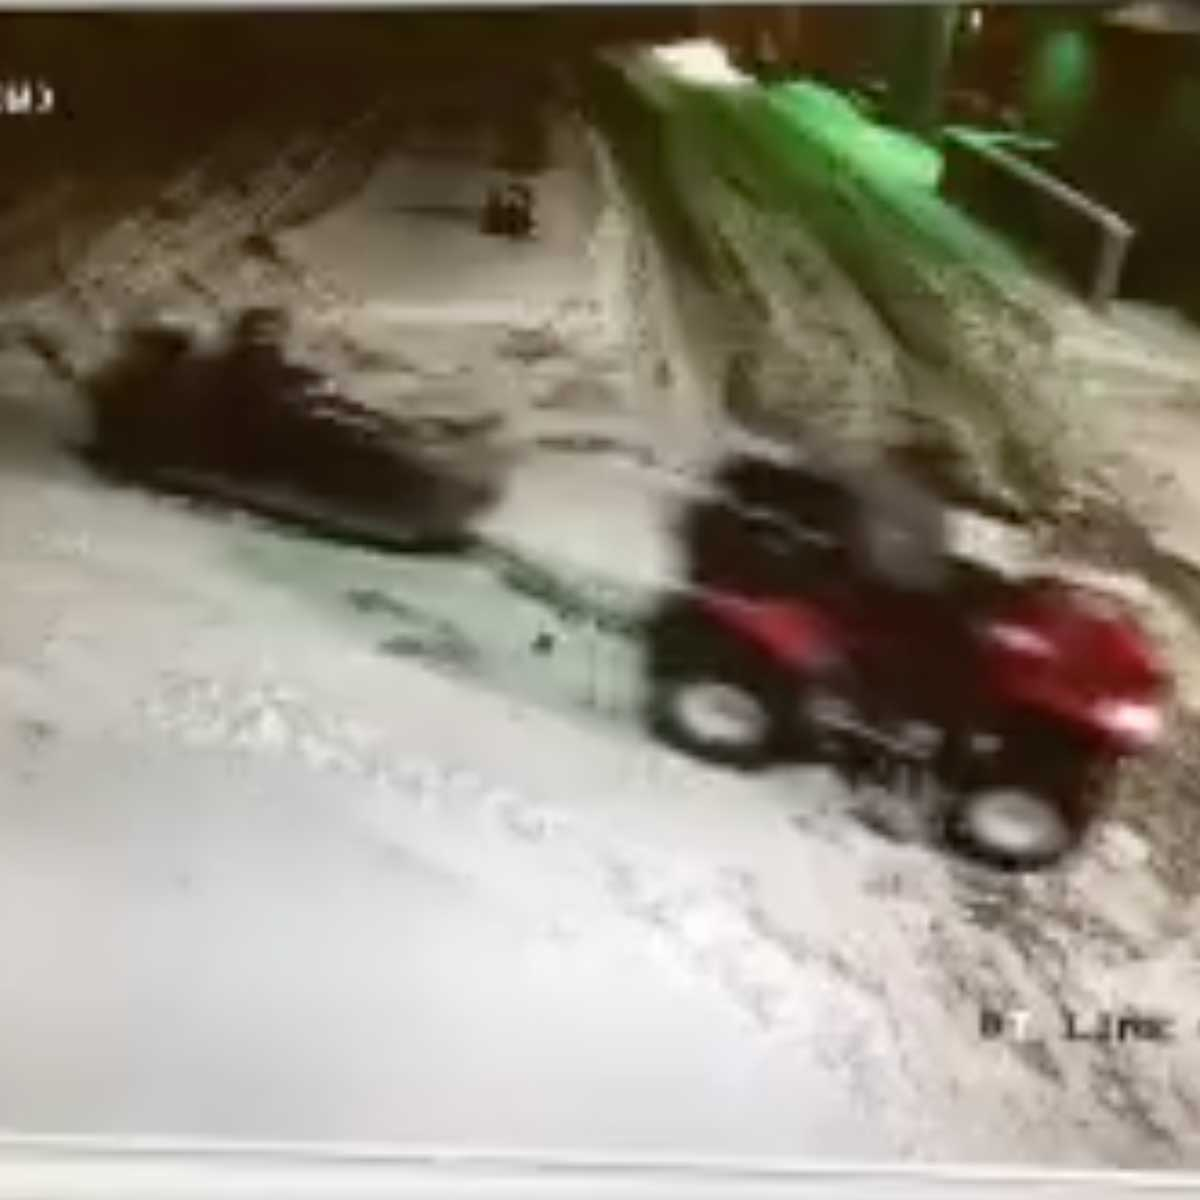Can you describe the setting and what is happening with the vehicles? The image appears to depict a snow-covered area, possibly during nighttime given the lighting. There are visible tracks on the snow, indicating recent movement. The main focus is on two vehicles: an ATV in the foreground and a smaller, darker object further away. The ATV seems to be in motion, potentially heading towards the smaller object. Given the snowy and possibly icy conditions, vehicle control may be challenging, increasing the chances of a near collision or a careful maneuver. 